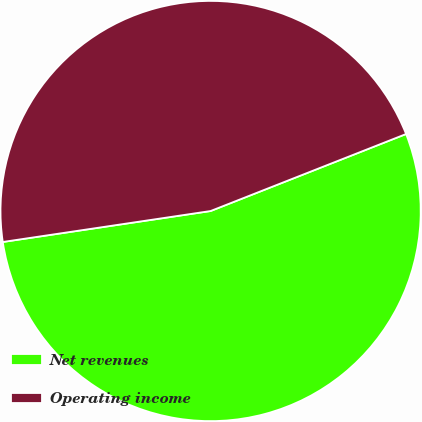Convert chart. <chart><loc_0><loc_0><loc_500><loc_500><pie_chart><fcel>Net revenues<fcel>Operating income<nl><fcel>53.62%<fcel>46.38%<nl></chart> 